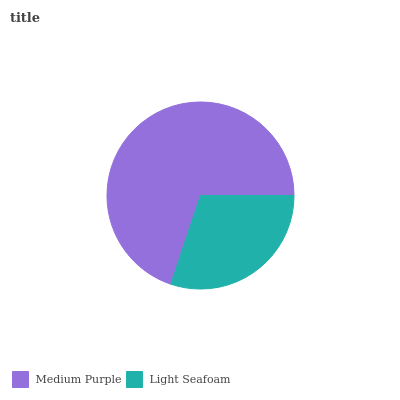Is Light Seafoam the minimum?
Answer yes or no. Yes. Is Medium Purple the maximum?
Answer yes or no. Yes. Is Light Seafoam the maximum?
Answer yes or no. No. Is Medium Purple greater than Light Seafoam?
Answer yes or no. Yes. Is Light Seafoam less than Medium Purple?
Answer yes or no. Yes. Is Light Seafoam greater than Medium Purple?
Answer yes or no. No. Is Medium Purple less than Light Seafoam?
Answer yes or no. No. Is Medium Purple the high median?
Answer yes or no. Yes. Is Light Seafoam the low median?
Answer yes or no. Yes. Is Light Seafoam the high median?
Answer yes or no. No. Is Medium Purple the low median?
Answer yes or no. No. 